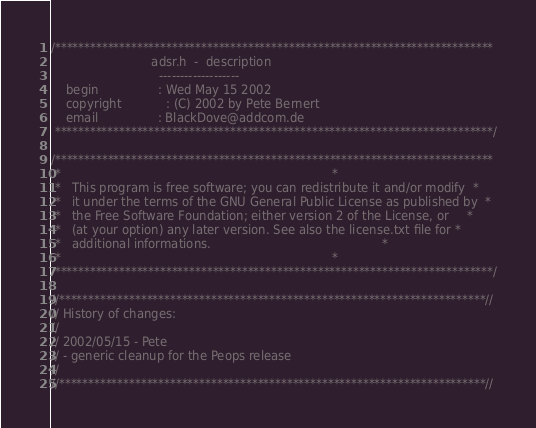<code> <loc_0><loc_0><loc_500><loc_500><_C_>/***************************************************************************
                           adsr.h  -  description
                             -------------------
    begin                : Wed May 15 2002
    copyright            : (C) 2002 by Pete Bernert
    email                : BlackDove@addcom.de
 ***************************************************************************/

/***************************************************************************
 *                                                                         *
 *   This program is free software; you can redistribute it and/or modify  *
 *   it under the terms of the GNU General Public License as published by  *
 *   the Free Software Foundation; either version 2 of the License, or     *
 *   (at your option) any later version. See also the license.txt file for *
 *   additional informations.                                              *
 *                                                                         *
 ***************************************************************************/

//*************************************************************************//
// History of changes:
//
// 2002/05/15 - Pete
// - generic cleanup for the Peops release
//
//*************************************************************************//
</code> 